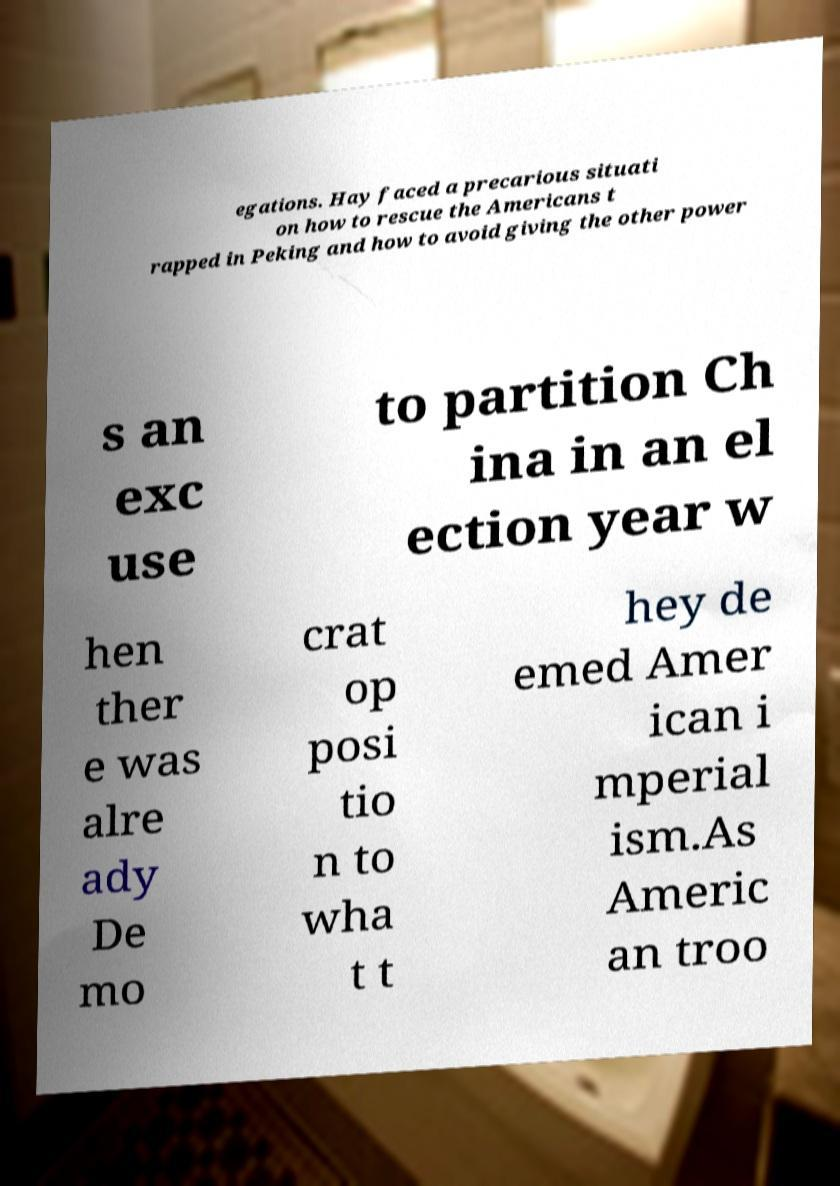There's text embedded in this image that I need extracted. Can you transcribe it verbatim? egations. Hay faced a precarious situati on how to rescue the Americans t rapped in Peking and how to avoid giving the other power s an exc use to partition Ch ina in an el ection year w hen ther e was alre ady De mo crat op posi tio n to wha t t hey de emed Amer ican i mperial ism.As Americ an troo 